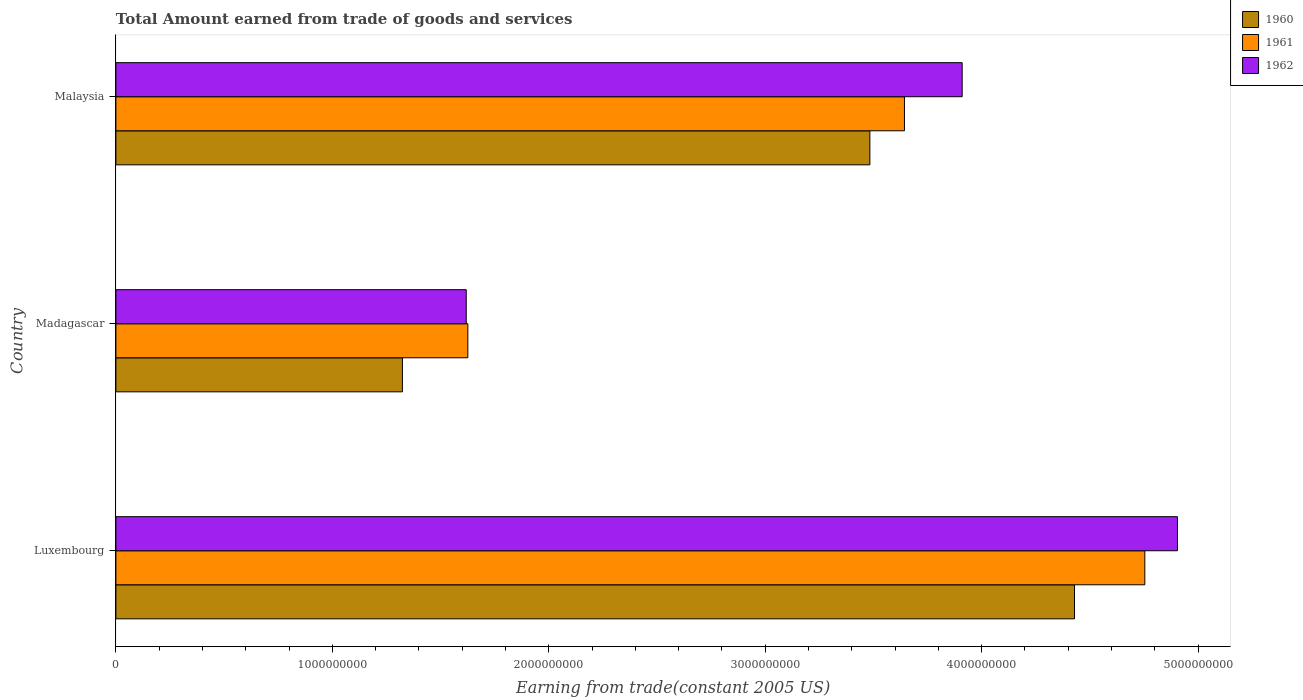How many different coloured bars are there?
Keep it short and to the point. 3. Are the number of bars per tick equal to the number of legend labels?
Your response must be concise. Yes. What is the label of the 2nd group of bars from the top?
Your answer should be very brief. Madagascar. What is the total amount earned by trading goods and services in 1960 in Luxembourg?
Your response must be concise. 4.43e+09. Across all countries, what is the maximum total amount earned by trading goods and services in 1962?
Ensure brevity in your answer.  4.90e+09. Across all countries, what is the minimum total amount earned by trading goods and services in 1960?
Keep it short and to the point. 1.32e+09. In which country was the total amount earned by trading goods and services in 1962 maximum?
Ensure brevity in your answer.  Luxembourg. In which country was the total amount earned by trading goods and services in 1960 minimum?
Ensure brevity in your answer.  Madagascar. What is the total total amount earned by trading goods and services in 1960 in the graph?
Offer a terse response. 9.24e+09. What is the difference between the total amount earned by trading goods and services in 1960 in Luxembourg and that in Malaysia?
Make the answer very short. 9.45e+08. What is the difference between the total amount earned by trading goods and services in 1962 in Malaysia and the total amount earned by trading goods and services in 1960 in Madagascar?
Keep it short and to the point. 2.59e+09. What is the average total amount earned by trading goods and services in 1960 per country?
Provide a short and direct response. 3.08e+09. What is the difference between the total amount earned by trading goods and services in 1961 and total amount earned by trading goods and services in 1960 in Malaysia?
Provide a succinct answer. 1.60e+08. What is the ratio of the total amount earned by trading goods and services in 1960 in Luxembourg to that in Malaysia?
Ensure brevity in your answer.  1.27. Is the total amount earned by trading goods and services in 1960 in Luxembourg less than that in Malaysia?
Your answer should be very brief. No. What is the difference between the highest and the second highest total amount earned by trading goods and services in 1962?
Give a very brief answer. 9.95e+08. What is the difference between the highest and the lowest total amount earned by trading goods and services in 1961?
Give a very brief answer. 3.13e+09. What does the 3rd bar from the top in Madagascar represents?
Keep it short and to the point. 1960. What does the 1st bar from the bottom in Luxembourg represents?
Offer a terse response. 1960. Is it the case that in every country, the sum of the total amount earned by trading goods and services in 1960 and total amount earned by trading goods and services in 1961 is greater than the total amount earned by trading goods and services in 1962?
Your response must be concise. Yes. Are all the bars in the graph horizontal?
Your answer should be compact. Yes. How many countries are there in the graph?
Ensure brevity in your answer.  3. Does the graph contain any zero values?
Offer a terse response. No. Where does the legend appear in the graph?
Give a very brief answer. Top right. What is the title of the graph?
Provide a succinct answer. Total Amount earned from trade of goods and services. What is the label or title of the X-axis?
Your response must be concise. Earning from trade(constant 2005 US). What is the Earning from trade(constant 2005 US) of 1960 in Luxembourg?
Offer a terse response. 4.43e+09. What is the Earning from trade(constant 2005 US) in 1961 in Luxembourg?
Your response must be concise. 4.75e+09. What is the Earning from trade(constant 2005 US) of 1962 in Luxembourg?
Your response must be concise. 4.90e+09. What is the Earning from trade(constant 2005 US) of 1960 in Madagascar?
Your response must be concise. 1.32e+09. What is the Earning from trade(constant 2005 US) of 1961 in Madagascar?
Keep it short and to the point. 1.63e+09. What is the Earning from trade(constant 2005 US) of 1962 in Madagascar?
Your answer should be compact. 1.62e+09. What is the Earning from trade(constant 2005 US) in 1960 in Malaysia?
Your answer should be compact. 3.48e+09. What is the Earning from trade(constant 2005 US) of 1961 in Malaysia?
Offer a terse response. 3.64e+09. What is the Earning from trade(constant 2005 US) of 1962 in Malaysia?
Offer a very short reply. 3.91e+09. Across all countries, what is the maximum Earning from trade(constant 2005 US) of 1960?
Your answer should be compact. 4.43e+09. Across all countries, what is the maximum Earning from trade(constant 2005 US) of 1961?
Your answer should be compact. 4.75e+09. Across all countries, what is the maximum Earning from trade(constant 2005 US) in 1962?
Ensure brevity in your answer.  4.90e+09. Across all countries, what is the minimum Earning from trade(constant 2005 US) in 1960?
Provide a succinct answer. 1.32e+09. Across all countries, what is the minimum Earning from trade(constant 2005 US) of 1961?
Provide a succinct answer. 1.63e+09. Across all countries, what is the minimum Earning from trade(constant 2005 US) of 1962?
Offer a terse response. 1.62e+09. What is the total Earning from trade(constant 2005 US) of 1960 in the graph?
Provide a succinct answer. 9.24e+09. What is the total Earning from trade(constant 2005 US) of 1961 in the graph?
Your answer should be compact. 1.00e+1. What is the total Earning from trade(constant 2005 US) of 1962 in the graph?
Ensure brevity in your answer.  1.04e+1. What is the difference between the Earning from trade(constant 2005 US) in 1960 in Luxembourg and that in Madagascar?
Provide a short and direct response. 3.11e+09. What is the difference between the Earning from trade(constant 2005 US) in 1961 in Luxembourg and that in Madagascar?
Offer a very short reply. 3.13e+09. What is the difference between the Earning from trade(constant 2005 US) of 1962 in Luxembourg and that in Madagascar?
Your response must be concise. 3.29e+09. What is the difference between the Earning from trade(constant 2005 US) in 1960 in Luxembourg and that in Malaysia?
Ensure brevity in your answer.  9.45e+08. What is the difference between the Earning from trade(constant 2005 US) of 1961 in Luxembourg and that in Malaysia?
Provide a succinct answer. 1.11e+09. What is the difference between the Earning from trade(constant 2005 US) in 1962 in Luxembourg and that in Malaysia?
Your answer should be compact. 9.95e+08. What is the difference between the Earning from trade(constant 2005 US) in 1960 in Madagascar and that in Malaysia?
Your answer should be compact. -2.16e+09. What is the difference between the Earning from trade(constant 2005 US) in 1961 in Madagascar and that in Malaysia?
Give a very brief answer. -2.02e+09. What is the difference between the Earning from trade(constant 2005 US) in 1962 in Madagascar and that in Malaysia?
Make the answer very short. -2.29e+09. What is the difference between the Earning from trade(constant 2005 US) of 1960 in Luxembourg and the Earning from trade(constant 2005 US) of 1961 in Madagascar?
Ensure brevity in your answer.  2.80e+09. What is the difference between the Earning from trade(constant 2005 US) of 1960 in Luxembourg and the Earning from trade(constant 2005 US) of 1962 in Madagascar?
Ensure brevity in your answer.  2.81e+09. What is the difference between the Earning from trade(constant 2005 US) of 1961 in Luxembourg and the Earning from trade(constant 2005 US) of 1962 in Madagascar?
Offer a terse response. 3.14e+09. What is the difference between the Earning from trade(constant 2005 US) in 1960 in Luxembourg and the Earning from trade(constant 2005 US) in 1961 in Malaysia?
Offer a terse response. 7.86e+08. What is the difference between the Earning from trade(constant 2005 US) in 1960 in Luxembourg and the Earning from trade(constant 2005 US) in 1962 in Malaysia?
Make the answer very short. 5.19e+08. What is the difference between the Earning from trade(constant 2005 US) in 1961 in Luxembourg and the Earning from trade(constant 2005 US) in 1962 in Malaysia?
Your response must be concise. 8.44e+08. What is the difference between the Earning from trade(constant 2005 US) of 1960 in Madagascar and the Earning from trade(constant 2005 US) of 1961 in Malaysia?
Provide a succinct answer. -2.32e+09. What is the difference between the Earning from trade(constant 2005 US) in 1960 in Madagascar and the Earning from trade(constant 2005 US) in 1962 in Malaysia?
Offer a very short reply. -2.59e+09. What is the difference between the Earning from trade(constant 2005 US) in 1961 in Madagascar and the Earning from trade(constant 2005 US) in 1962 in Malaysia?
Your answer should be compact. -2.28e+09. What is the average Earning from trade(constant 2005 US) of 1960 per country?
Your answer should be compact. 3.08e+09. What is the average Earning from trade(constant 2005 US) of 1961 per country?
Provide a short and direct response. 3.34e+09. What is the average Earning from trade(constant 2005 US) of 1962 per country?
Your answer should be compact. 3.48e+09. What is the difference between the Earning from trade(constant 2005 US) in 1960 and Earning from trade(constant 2005 US) in 1961 in Luxembourg?
Your answer should be very brief. -3.25e+08. What is the difference between the Earning from trade(constant 2005 US) of 1960 and Earning from trade(constant 2005 US) of 1962 in Luxembourg?
Your answer should be very brief. -4.76e+08. What is the difference between the Earning from trade(constant 2005 US) of 1961 and Earning from trade(constant 2005 US) of 1962 in Luxembourg?
Your answer should be very brief. -1.51e+08. What is the difference between the Earning from trade(constant 2005 US) in 1960 and Earning from trade(constant 2005 US) in 1961 in Madagascar?
Provide a succinct answer. -3.02e+08. What is the difference between the Earning from trade(constant 2005 US) of 1960 and Earning from trade(constant 2005 US) of 1962 in Madagascar?
Offer a terse response. -2.95e+08. What is the difference between the Earning from trade(constant 2005 US) in 1961 and Earning from trade(constant 2005 US) in 1962 in Madagascar?
Keep it short and to the point. 7.38e+06. What is the difference between the Earning from trade(constant 2005 US) of 1960 and Earning from trade(constant 2005 US) of 1961 in Malaysia?
Make the answer very short. -1.60e+08. What is the difference between the Earning from trade(constant 2005 US) of 1960 and Earning from trade(constant 2005 US) of 1962 in Malaysia?
Provide a succinct answer. -4.26e+08. What is the difference between the Earning from trade(constant 2005 US) of 1961 and Earning from trade(constant 2005 US) of 1962 in Malaysia?
Ensure brevity in your answer.  -2.67e+08. What is the ratio of the Earning from trade(constant 2005 US) of 1960 in Luxembourg to that in Madagascar?
Make the answer very short. 3.35. What is the ratio of the Earning from trade(constant 2005 US) in 1961 in Luxembourg to that in Madagascar?
Your response must be concise. 2.92. What is the ratio of the Earning from trade(constant 2005 US) of 1962 in Luxembourg to that in Madagascar?
Make the answer very short. 3.03. What is the ratio of the Earning from trade(constant 2005 US) of 1960 in Luxembourg to that in Malaysia?
Ensure brevity in your answer.  1.27. What is the ratio of the Earning from trade(constant 2005 US) of 1961 in Luxembourg to that in Malaysia?
Offer a terse response. 1.3. What is the ratio of the Earning from trade(constant 2005 US) of 1962 in Luxembourg to that in Malaysia?
Keep it short and to the point. 1.25. What is the ratio of the Earning from trade(constant 2005 US) in 1960 in Madagascar to that in Malaysia?
Give a very brief answer. 0.38. What is the ratio of the Earning from trade(constant 2005 US) of 1961 in Madagascar to that in Malaysia?
Your answer should be compact. 0.45. What is the ratio of the Earning from trade(constant 2005 US) in 1962 in Madagascar to that in Malaysia?
Give a very brief answer. 0.41. What is the difference between the highest and the second highest Earning from trade(constant 2005 US) in 1960?
Keep it short and to the point. 9.45e+08. What is the difference between the highest and the second highest Earning from trade(constant 2005 US) of 1961?
Make the answer very short. 1.11e+09. What is the difference between the highest and the second highest Earning from trade(constant 2005 US) of 1962?
Give a very brief answer. 9.95e+08. What is the difference between the highest and the lowest Earning from trade(constant 2005 US) in 1960?
Keep it short and to the point. 3.11e+09. What is the difference between the highest and the lowest Earning from trade(constant 2005 US) of 1961?
Offer a terse response. 3.13e+09. What is the difference between the highest and the lowest Earning from trade(constant 2005 US) of 1962?
Give a very brief answer. 3.29e+09. 